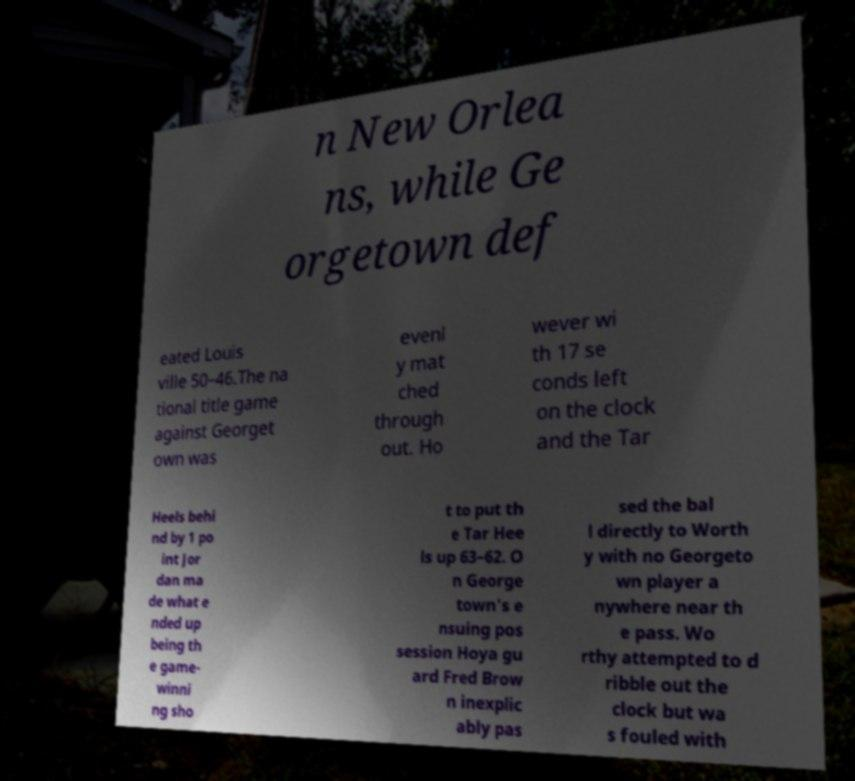Please identify and transcribe the text found in this image. n New Orlea ns, while Ge orgetown def eated Louis ville 50–46.The na tional title game against Georget own was evenl y mat ched through out. Ho wever wi th 17 se conds left on the clock and the Tar Heels behi nd by 1 po int Jor dan ma de what e nded up being th e game- winni ng sho t to put th e Tar Hee ls up 63–62. O n George town's e nsuing pos session Hoya gu ard Fred Brow n inexplic ably pas sed the bal l directly to Worth y with no Georgeto wn player a nywhere near th e pass. Wo rthy attempted to d ribble out the clock but wa s fouled with 